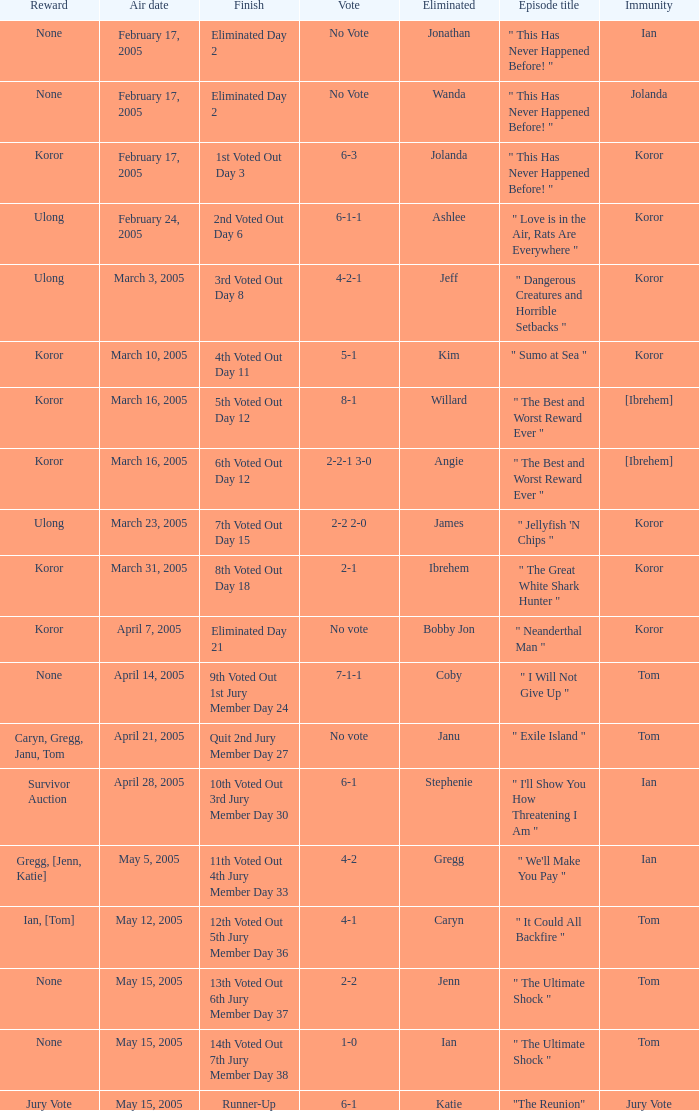How many votes were taken when the outcome was "6th voted out day 12"? 1.0. 